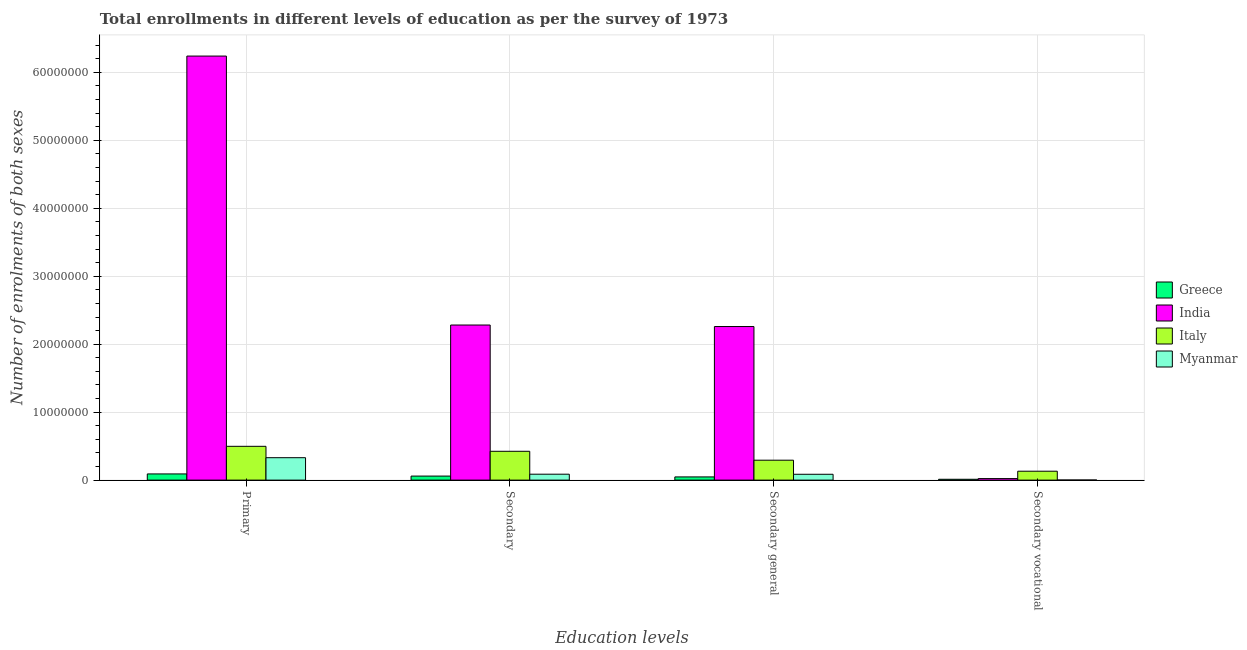How many different coloured bars are there?
Your answer should be very brief. 4. How many groups of bars are there?
Ensure brevity in your answer.  4. Are the number of bars per tick equal to the number of legend labels?
Provide a short and direct response. Yes. Are the number of bars on each tick of the X-axis equal?
Provide a succinct answer. Yes. How many bars are there on the 1st tick from the right?
Ensure brevity in your answer.  4. What is the label of the 2nd group of bars from the left?
Offer a very short reply. Secondary. What is the number of enrolments in secondary general education in India?
Your answer should be very brief. 2.26e+07. Across all countries, what is the maximum number of enrolments in secondary education?
Offer a terse response. 2.28e+07. Across all countries, what is the minimum number of enrolments in secondary vocational education?
Give a very brief answer. 1.12e+04. In which country was the number of enrolments in primary education maximum?
Keep it short and to the point. India. What is the total number of enrolments in secondary education in the graph?
Keep it short and to the point. 2.85e+07. What is the difference between the number of enrolments in primary education in Greece and that in India?
Your response must be concise. -6.15e+07. What is the difference between the number of enrolments in secondary education in Greece and the number of enrolments in secondary vocational education in Italy?
Give a very brief answer. -7.16e+05. What is the average number of enrolments in secondary education per country?
Make the answer very short. 7.13e+06. What is the difference between the number of enrolments in secondary vocational education and number of enrolments in secondary general education in India?
Your answer should be very brief. -2.24e+07. In how many countries, is the number of enrolments in secondary general education greater than 48000000 ?
Keep it short and to the point. 0. What is the ratio of the number of enrolments in primary education in Myanmar to that in India?
Your response must be concise. 0.05. Is the number of enrolments in secondary education in India less than that in Myanmar?
Offer a very short reply. No. Is the difference between the number of enrolments in secondary general education in Myanmar and Greece greater than the difference between the number of enrolments in secondary education in Myanmar and Greece?
Make the answer very short. Yes. What is the difference between the highest and the second highest number of enrolments in secondary vocational education?
Your answer should be compact. 1.08e+06. What is the difference between the highest and the lowest number of enrolments in secondary vocational education?
Your answer should be compact. 1.30e+06. In how many countries, is the number of enrolments in primary education greater than the average number of enrolments in primary education taken over all countries?
Your answer should be compact. 1. What does the 4th bar from the left in Primary represents?
Ensure brevity in your answer.  Myanmar. How many countries are there in the graph?
Your answer should be very brief. 4. Are the values on the major ticks of Y-axis written in scientific E-notation?
Offer a very short reply. No. What is the title of the graph?
Offer a terse response. Total enrollments in different levels of education as per the survey of 1973. What is the label or title of the X-axis?
Keep it short and to the point. Education levels. What is the label or title of the Y-axis?
Give a very brief answer. Number of enrolments of both sexes. What is the Number of enrolments of both sexes in Greece in Primary?
Your answer should be very brief. 9.09e+05. What is the Number of enrolments of both sexes of India in Primary?
Provide a short and direct response. 6.24e+07. What is the Number of enrolments of both sexes of Italy in Primary?
Make the answer very short. 4.97e+06. What is the Number of enrolments of both sexes in Myanmar in Primary?
Provide a short and direct response. 3.30e+06. What is the Number of enrolments of both sexes in Greece in Secondary?
Give a very brief answer. 5.93e+05. What is the Number of enrolments of both sexes in India in Secondary?
Provide a short and direct response. 2.28e+07. What is the Number of enrolments of both sexes of Italy in Secondary?
Provide a short and direct response. 4.24e+06. What is the Number of enrolments of both sexes of Myanmar in Secondary?
Offer a very short reply. 8.72e+05. What is the Number of enrolments of both sexes of Greece in Secondary general?
Keep it short and to the point. 4.70e+05. What is the Number of enrolments of both sexes of India in Secondary general?
Provide a succinct answer. 2.26e+07. What is the Number of enrolments of both sexes of Italy in Secondary general?
Offer a very short reply. 2.93e+06. What is the Number of enrolments of both sexes in Myanmar in Secondary general?
Give a very brief answer. 8.61e+05. What is the Number of enrolments of both sexes of Greece in Secondary vocational?
Your response must be concise. 1.23e+05. What is the Number of enrolments of both sexes in India in Secondary vocational?
Your response must be concise. 2.25e+05. What is the Number of enrolments of both sexes of Italy in Secondary vocational?
Ensure brevity in your answer.  1.31e+06. What is the Number of enrolments of both sexes in Myanmar in Secondary vocational?
Provide a short and direct response. 1.12e+04. Across all Education levels, what is the maximum Number of enrolments of both sexes in Greece?
Your answer should be compact. 9.09e+05. Across all Education levels, what is the maximum Number of enrolments of both sexes of India?
Give a very brief answer. 6.24e+07. Across all Education levels, what is the maximum Number of enrolments of both sexes in Italy?
Offer a very short reply. 4.97e+06. Across all Education levels, what is the maximum Number of enrolments of both sexes of Myanmar?
Ensure brevity in your answer.  3.30e+06. Across all Education levels, what is the minimum Number of enrolments of both sexes of Greece?
Your response must be concise. 1.23e+05. Across all Education levels, what is the minimum Number of enrolments of both sexes of India?
Provide a succinct answer. 2.25e+05. Across all Education levels, what is the minimum Number of enrolments of both sexes in Italy?
Keep it short and to the point. 1.31e+06. Across all Education levels, what is the minimum Number of enrolments of both sexes of Myanmar?
Provide a short and direct response. 1.12e+04. What is the total Number of enrolments of both sexes of Greece in the graph?
Your answer should be compact. 2.10e+06. What is the total Number of enrolments of both sexes in India in the graph?
Give a very brief answer. 1.08e+08. What is the total Number of enrolments of both sexes of Italy in the graph?
Provide a succinct answer. 1.35e+07. What is the total Number of enrolments of both sexes of Myanmar in the graph?
Offer a very short reply. 5.04e+06. What is the difference between the Number of enrolments of both sexes in Greece in Primary and that in Secondary?
Your answer should be very brief. 3.16e+05. What is the difference between the Number of enrolments of both sexes of India in Primary and that in Secondary?
Provide a succinct answer. 3.96e+07. What is the difference between the Number of enrolments of both sexes of Italy in Primary and that in Secondary?
Give a very brief answer. 7.32e+05. What is the difference between the Number of enrolments of both sexes of Myanmar in Primary and that in Secondary?
Provide a short and direct response. 2.43e+06. What is the difference between the Number of enrolments of both sexes of Greece in Primary and that in Secondary general?
Keep it short and to the point. 4.39e+05. What is the difference between the Number of enrolments of both sexes of India in Primary and that in Secondary general?
Offer a very short reply. 3.98e+07. What is the difference between the Number of enrolments of both sexes of Italy in Primary and that in Secondary general?
Give a very brief answer. 2.04e+06. What is the difference between the Number of enrolments of both sexes of Myanmar in Primary and that in Secondary general?
Your answer should be compact. 2.44e+06. What is the difference between the Number of enrolments of both sexes of Greece in Primary and that in Secondary vocational?
Keep it short and to the point. 7.86e+05. What is the difference between the Number of enrolments of both sexes in India in Primary and that in Secondary vocational?
Provide a short and direct response. 6.22e+07. What is the difference between the Number of enrolments of both sexes of Italy in Primary and that in Secondary vocational?
Your answer should be compact. 3.66e+06. What is the difference between the Number of enrolments of both sexes in Myanmar in Primary and that in Secondary vocational?
Your response must be concise. 3.29e+06. What is the difference between the Number of enrolments of both sexes in Greece in Secondary and that in Secondary general?
Keep it short and to the point. 1.23e+05. What is the difference between the Number of enrolments of both sexes in India in Secondary and that in Secondary general?
Make the answer very short. 2.25e+05. What is the difference between the Number of enrolments of both sexes in Italy in Secondary and that in Secondary general?
Your response must be concise. 1.31e+06. What is the difference between the Number of enrolments of both sexes of Myanmar in Secondary and that in Secondary general?
Offer a very short reply. 1.12e+04. What is the difference between the Number of enrolments of both sexes of Greece in Secondary and that in Secondary vocational?
Provide a short and direct response. 4.70e+05. What is the difference between the Number of enrolments of both sexes in India in Secondary and that in Secondary vocational?
Your answer should be compact. 2.26e+07. What is the difference between the Number of enrolments of both sexes in Italy in Secondary and that in Secondary vocational?
Your response must be concise. 2.93e+06. What is the difference between the Number of enrolments of both sexes in Myanmar in Secondary and that in Secondary vocational?
Ensure brevity in your answer.  8.61e+05. What is the difference between the Number of enrolments of both sexes in Greece in Secondary general and that in Secondary vocational?
Your response must be concise. 3.47e+05. What is the difference between the Number of enrolments of both sexes in India in Secondary general and that in Secondary vocational?
Your answer should be very brief. 2.24e+07. What is the difference between the Number of enrolments of both sexes in Italy in Secondary general and that in Secondary vocational?
Offer a very short reply. 1.62e+06. What is the difference between the Number of enrolments of both sexes of Myanmar in Secondary general and that in Secondary vocational?
Ensure brevity in your answer.  8.49e+05. What is the difference between the Number of enrolments of both sexes of Greece in Primary and the Number of enrolments of both sexes of India in Secondary?
Offer a very short reply. -2.19e+07. What is the difference between the Number of enrolments of both sexes in Greece in Primary and the Number of enrolments of both sexes in Italy in Secondary?
Make the answer very short. -3.33e+06. What is the difference between the Number of enrolments of both sexes of Greece in Primary and the Number of enrolments of both sexes of Myanmar in Secondary?
Give a very brief answer. 3.76e+04. What is the difference between the Number of enrolments of both sexes in India in Primary and the Number of enrolments of both sexes in Italy in Secondary?
Offer a terse response. 5.82e+07. What is the difference between the Number of enrolments of both sexes of India in Primary and the Number of enrolments of both sexes of Myanmar in Secondary?
Make the answer very short. 6.15e+07. What is the difference between the Number of enrolments of both sexes of Italy in Primary and the Number of enrolments of both sexes of Myanmar in Secondary?
Offer a very short reply. 4.10e+06. What is the difference between the Number of enrolments of both sexes of Greece in Primary and the Number of enrolments of both sexes of India in Secondary general?
Provide a short and direct response. -2.17e+07. What is the difference between the Number of enrolments of both sexes in Greece in Primary and the Number of enrolments of both sexes in Italy in Secondary general?
Your answer should be compact. -2.02e+06. What is the difference between the Number of enrolments of both sexes of Greece in Primary and the Number of enrolments of both sexes of Myanmar in Secondary general?
Provide a short and direct response. 4.88e+04. What is the difference between the Number of enrolments of both sexes in India in Primary and the Number of enrolments of both sexes in Italy in Secondary general?
Offer a very short reply. 5.95e+07. What is the difference between the Number of enrolments of both sexes of India in Primary and the Number of enrolments of both sexes of Myanmar in Secondary general?
Ensure brevity in your answer.  6.15e+07. What is the difference between the Number of enrolments of both sexes of Italy in Primary and the Number of enrolments of both sexes of Myanmar in Secondary general?
Make the answer very short. 4.11e+06. What is the difference between the Number of enrolments of both sexes in Greece in Primary and the Number of enrolments of both sexes in India in Secondary vocational?
Ensure brevity in your answer.  6.85e+05. What is the difference between the Number of enrolments of both sexes in Greece in Primary and the Number of enrolments of both sexes in Italy in Secondary vocational?
Your answer should be very brief. -4.00e+05. What is the difference between the Number of enrolments of both sexes of Greece in Primary and the Number of enrolments of both sexes of Myanmar in Secondary vocational?
Your answer should be compact. 8.98e+05. What is the difference between the Number of enrolments of both sexes of India in Primary and the Number of enrolments of both sexes of Italy in Secondary vocational?
Keep it short and to the point. 6.11e+07. What is the difference between the Number of enrolments of both sexes of India in Primary and the Number of enrolments of both sexes of Myanmar in Secondary vocational?
Keep it short and to the point. 6.24e+07. What is the difference between the Number of enrolments of both sexes in Italy in Primary and the Number of enrolments of both sexes in Myanmar in Secondary vocational?
Offer a terse response. 4.96e+06. What is the difference between the Number of enrolments of both sexes of Greece in Secondary and the Number of enrolments of both sexes of India in Secondary general?
Ensure brevity in your answer.  -2.20e+07. What is the difference between the Number of enrolments of both sexes in Greece in Secondary and the Number of enrolments of both sexes in Italy in Secondary general?
Keep it short and to the point. -2.34e+06. What is the difference between the Number of enrolments of both sexes of Greece in Secondary and the Number of enrolments of both sexes of Myanmar in Secondary general?
Your answer should be very brief. -2.67e+05. What is the difference between the Number of enrolments of both sexes in India in Secondary and the Number of enrolments of both sexes in Italy in Secondary general?
Offer a terse response. 1.99e+07. What is the difference between the Number of enrolments of both sexes in India in Secondary and the Number of enrolments of both sexes in Myanmar in Secondary general?
Ensure brevity in your answer.  2.20e+07. What is the difference between the Number of enrolments of both sexes of Italy in Secondary and the Number of enrolments of both sexes of Myanmar in Secondary general?
Provide a short and direct response. 3.38e+06. What is the difference between the Number of enrolments of both sexes of Greece in Secondary and the Number of enrolments of both sexes of India in Secondary vocational?
Give a very brief answer. 3.69e+05. What is the difference between the Number of enrolments of both sexes of Greece in Secondary and the Number of enrolments of both sexes of Italy in Secondary vocational?
Your response must be concise. -7.16e+05. What is the difference between the Number of enrolments of both sexes of Greece in Secondary and the Number of enrolments of both sexes of Myanmar in Secondary vocational?
Make the answer very short. 5.82e+05. What is the difference between the Number of enrolments of both sexes of India in Secondary and the Number of enrolments of both sexes of Italy in Secondary vocational?
Provide a succinct answer. 2.15e+07. What is the difference between the Number of enrolments of both sexes of India in Secondary and the Number of enrolments of both sexes of Myanmar in Secondary vocational?
Your response must be concise. 2.28e+07. What is the difference between the Number of enrolments of both sexes in Italy in Secondary and the Number of enrolments of both sexes in Myanmar in Secondary vocational?
Your response must be concise. 4.23e+06. What is the difference between the Number of enrolments of both sexes of Greece in Secondary general and the Number of enrolments of both sexes of India in Secondary vocational?
Offer a terse response. 2.46e+05. What is the difference between the Number of enrolments of both sexes in Greece in Secondary general and the Number of enrolments of both sexes in Italy in Secondary vocational?
Offer a terse response. -8.39e+05. What is the difference between the Number of enrolments of both sexes of Greece in Secondary general and the Number of enrolments of both sexes of Myanmar in Secondary vocational?
Offer a terse response. 4.59e+05. What is the difference between the Number of enrolments of both sexes in India in Secondary general and the Number of enrolments of both sexes in Italy in Secondary vocational?
Provide a short and direct response. 2.13e+07. What is the difference between the Number of enrolments of both sexes in India in Secondary general and the Number of enrolments of both sexes in Myanmar in Secondary vocational?
Keep it short and to the point. 2.26e+07. What is the difference between the Number of enrolments of both sexes in Italy in Secondary general and the Number of enrolments of both sexes in Myanmar in Secondary vocational?
Your answer should be very brief. 2.92e+06. What is the average Number of enrolments of both sexes of Greece per Education levels?
Provide a succinct answer. 5.24e+05. What is the average Number of enrolments of both sexes in India per Education levels?
Give a very brief answer. 2.70e+07. What is the average Number of enrolments of both sexes in Italy per Education levels?
Provide a succinct answer. 3.36e+06. What is the average Number of enrolments of both sexes of Myanmar per Education levels?
Your response must be concise. 1.26e+06. What is the difference between the Number of enrolments of both sexes of Greece and Number of enrolments of both sexes of India in Primary?
Keep it short and to the point. -6.15e+07. What is the difference between the Number of enrolments of both sexes of Greece and Number of enrolments of both sexes of Italy in Primary?
Offer a terse response. -4.06e+06. What is the difference between the Number of enrolments of both sexes in Greece and Number of enrolments of both sexes in Myanmar in Primary?
Provide a short and direct response. -2.39e+06. What is the difference between the Number of enrolments of both sexes of India and Number of enrolments of both sexes of Italy in Primary?
Keep it short and to the point. 5.74e+07. What is the difference between the Number of enrolments of both sexes in India and Number of enrolments of both sexes in Myanmar in Primary?
Provide a succinct answer. 5.91e+07. What is the difference between the Number of enrolments of both sexes in Italy and Number of enrolments of both sexes in Myanmar in Primary?
Your response must be concise. 1.67e+06. What is the difference between the Number of enrolments of both sexes of Greece and Number of enrolments of both sexes of India in Secondary?
Your answer should be compact. -2.22e+07. What is the difference between the Number of enrolments of both sexes of Greece and Number of enrolments of both sexes of Italy in Secondary?
Keep it short and to the point. -3.65e+06. What is the difference between the Number of enrolments of both sexes in Greece and Number of enrolments of both sexes in Myanmar in Secondary?
Give a very brief answer. -2.78e+05. What is the difference between the Number of enrolments of both sexes in India and Number of enrolments of both sexes in Italy in Secondary?
Keep it short and to the point. 1.86e+07. What is the difference between the Number of enrolments of both sexes of India and Number of enrolments of both sexes of Myanmar in Secondary?
Offer a very short reply. 2.20e+07. What is the difference between the Number of enrolments of both sexes in Italy and Number of enrolments of both sexes in Myanmar in Secondary?
Provide a succinct answer. 3.37e+06. What is the difference between the Number of enrolments of both sexes in Greece and Number of enrolments of both sexes in India in Secondary general?
Keep it short and to the point. -2.21e+07. What is the difference between the Number of enrolments of both sexes of Greece and Number of enrolments of both sexes of Italy in Secondary general?
Make the answer very short. -2.46e+06. What is the difference between the Number of enrolments of both sexes in Greece and Number of enrolments of both sexes in Myanmar in Secondary general?
Provide a succinct answer. -3.90e+05. What is the difference between the Number of enrolments of both sexes in India and Number of enrolments of both sexes in Italy in Secondary general?
Offer a terse response. 1.97e+07. What is the difference between the Number of enrolments of both sexes of India and Number of enrolments of both sexes of Myanmar in Secondary general?
Your answer should be very brief. 2.17e+07. What is the difference between the Number of enrolments of both sexes in Italy and Number of enrolments of both sexes in Myanmar in Secondary general?
Your answer should be compact. 2.07e+06. What is the difference between the Number of enrolments of both sexes of Greece and Number of enrolments of both sexes of India in Secondary vocational?
Offer a very short reply. -1.02e+05. What is the difference between the Number of enrolments of both sexes in Greece and Number of enrolments of both sexes in Italy in Secondary vocational?
Your answer should be very brief. -1.19e+06. What is the difference between the Number of enrolments of both sexes of Greece and Number of enrolments of both sexes of Myanmar in Secondary vocational?
Your response must be concise. 1.12e+05. What is the difference between the Number of enrolments of both sexes of India and Number of enrolments of both sexes of Italy in Secondary vocational?
Ensure brevity in your answer.  -1.08e+06. What is the difference between the Number of enrolments of both sexes in India and Number of enrolments of both sexes in Myanmar in Secondary vocational?
Make the answer very short. 2.13e+05. What is the difference between the Number of enrolments of both sexes of Italy and Number of enrolments of both sexes of Myanmar in Secondary vocational?
Provide a short and direct response. 1.30e+06. What is the ratio of the Number of enrolments of both sexes in Greece in Primary to that in Secondary?
Provide a short and direct response. 1.53. What is the ratio of the Number of enrolments of both sexes of India in Primary to that in Secondary?
Ensure brevity in your answer.  2.73. What is the ratio of the Number of enrolments of both sexes in Italy in Primary to that in Secondary?
Make the answer very short. 1.17. What is the ratio of the Number of enrolments of both sexes of Myanmar in Primary to that in Secondary?
Keep it short and to the point. 3.79. What is the ratio of the Number of enrolments of both sexes of Greece in Primary to that in Secondary general?
Provide a succinct answer. 1.93. What is the ratio of the Number of enrolments of both sexes of India in Primary to that in Secondary general?
Offer a very short reply. 2.76. What is the ratio of the Number of enrolments of both sexes of Italy in Primary to that in Secondary general?
Your response must be concise. 1.7. What is the ratio of the Number of enrolments of both sexes in Myanmar in Primary to that in Secondary general?
Your answer should be very brief. 3.83. What is the ratio of the Number of enrolments of both sexes in Greece in Primary to that in Secondary vocational?
Your answer should be compact. 7.39. What is the ratio of the Number of enrolments of both sexes in India in Primary to that in Secondary vocational?
Your response must be concise. 277.82. What is the ratio of the Number of enrolments of both sexes of Italy in Primary to that in Secondary vocational?
Ensure brevity in your answer.  3.8. What is the ratio of the Number of enrolments of both sexes in Myanmar in Primary to that in Secondary vocational?
Provide a succinct answer. 294.52. What is the ratio of the Number of enrolments of both sexes in Greece in Secondary to that in Secondary general?
Give a very brief answer. 1.26. What is the ratio of the Number of enrolments of both sexes in India in Secondary to that in Secondary general?
Provide a succinct answer. 1.01. What is the ratio of the Number of enrolments of both sexes of Italy in Secondary to that in Secondary general?
Your answer should be very brief. 1.45. What is the ratio of the Number of enrolments of both sexes of Greece in Secondary to that in Secondary vocational?
Provide a short and direct response. 4.82. What is the ratio of the Number of enrolments of both sexes in India in Secondary to that in Secondary vocational?
Provide a succinct answer. 101.62. What is the ratio of the Number of enrolments of both sexes of Italy in Secondary to that in Secondary vocational?
Offer a very short reply. 3.24. What is the ratio of the Number of enrolments of both sexes of Myanmar in Secondary to that in Secondary vocational?
Make the answer very short. 77.81. What is the ratio of the Number of enrolments of both sexes of Greece in Secondary general to that in Secondary vocational?
Keep it short and to the point. 3.82. What is the ratio of the Number of enrolments of both sexes in India in Secondary general to that in Secondary vocational?
Your answer should be very brief. 100.62. What is the ratio of the Number of enrolments of both sexes in Italy in Secondary general to that in Secondary vocational?
Ensure brevity in your answer.  2.24. What is the ratio of the Number of enrolments of both sexes of Myanmar in Secondary general to that in Secondary vocational?
Offer a terse response. 76.81. What is the difference between the highest and the second highest Number of enrolments of both sexes of Greece?
Your answer should be very brief. 3.16e+05. What is the difference between the highest and the second highest Number of enrolments of both sexes of India?
Offer a very short reply. 3.96e+07. What is the difference between the highest and the second highest Number of enrolments of both sexes in Italy?
Provide a succinct answer. 7.32e+05. What is the difference between the highest and the second highest Number of enrolments of both sexes of Myanmar?
Your response must be concise. 2.43e+06. What is the difference between the highest and the lowest Number of enrolments of both sexes in Greece?
Your response must be concise. 7.86e+05. What is the difference between the highest and the lowest Number of enrolments of both sexes in India?
Provide a succinct answer. 6.22e+07. What is the difference between the highest and the lowest Number of enrolments of both sexes in Italy?
Your response must be concise. 3.66e+06. What is the difference between the highest and the lowest Number of enrolments of both sexes in Myanmar?
Give a very brief answer. 3.29e+06. 